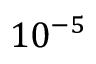Convert formula to latex. <formula><loc_0><loc_0><loc_500><loc_500>1 0 ^ { - 5 }</formula> 